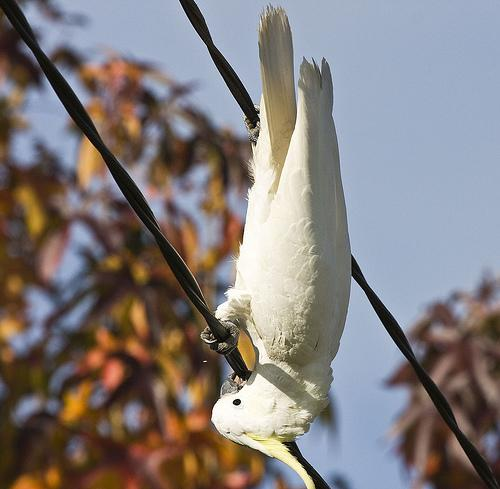Mention the primary subject in the image and their notable features. The image features an upside-down white parrot with a yellow headtop, a black eye, and a long tail, hanging by its feet on a black electrical wire. Create a brief narrative describing the scene in the image. Perched upside down, a curious white parrot with a yellow-feathered head and a long tail skillfully grips an electrical wire with its claws while also biting it with its beak. Offer a light-hearted and humorous description of the central subject and its behavior. Living life on the edge, the quirky white parrot inverts its world, daring to cling onto and chomp at the mysterious black wire with acrobatic flair. Briefly describe the main action happening in the picture. A white parrot, due to its mischievous nature, hangs upside down on a wire, using its beak and feet to grasp the electric line securely. Provide a creative and poetic description of the main object and its actions in the image. Gracefully draped in ivory plumage, an intriguing cockatoo adorned by a crown of sunlight careens upside down, while grasping and pecking at the ebony wire it dangles from. Provide a detailed description of the central object in the picture and its activity. An upside-down white parrot with a light yellow crest is hanging from a black wire, gripping it with its claws and biting the wire with its beak. Briefly describe the image's key subject and its surroundings. An upside-down white parrot with yellow head feathers is hanging from a black wire, with blurred trees and colorful leaves in the background. Concisely describe the focal point of the image and its actions. Hung upside down, a white parrot with a yellow feathered crown grips a black wire with its claws and beak. Convey in one sentence what the central object is doing and its most striking feature. A white parrot with a yellow head crest hangs upside down from a wire, gripping it with its feet and biting it with its beak. Explain what the main figure in the image is doing in a single sentence. The white parrot is hanging upside down from a wire by its claws, playfully biting on the wire with its beak. Do all the black wires in the image have a striped pattern on them? No captions mention any striped patterns on the wires, so stating there is one is misleading. Is the ocean visible in the sky between the branches of the tree? The sky appears in some captions (as in "sky between the wires") but there's no mention of the ocean, so asking about it is misleading. Are the feathers on the bird's head green and blue? The descriptors mention "yellow feathers on parrots head", so suggesting the feathers are green and blue is misleading. Is the parrot trying to eat a fruit on the tree? The parrot is described as biting the wire in several captions, so suggesting it's trying to eat a fruit on a tree is misleading. The bird seems to be sitting on a wooden branch. How thick is the branch? The bird is actually hanging on a wire ("bird on powerline", "parrot on wires", "black electrical wire") and not a wooden branch, so asking for thickness is misleading. Can you see a green bird sitting upright on the wire? The image has a "white parrot on wires" that is upside down, so describing it as green and sitting upright is incorrect and misleading. Please tell me how many small red eyes does the bird have? The captions describe the bird's eye as "tiny black eye", "the birds black eye", and "black eye on white bird", so suggesting it has multiple red eyes is misleading. I noticed a clear image of a tree in the background. What type of tree is it? The descriptors mention a "blurred image of a tree" and "colorful but blurry image of a tree", so asking for a specific type based on a clear image is misleading. Does the bird have blue wings spread wide while hanging on the wire? The bird's color is described as white, not blue (as in "white feathery body of the bird"), and there's no mention of its wings being spread, so making that assumption is misleading. Are the leaves on the tree next to the parrot purple? The descriptor actually says "multicolored leaves of the treebranch" and "orange and yellow leaves on tree", so implying the leaves are purple is misleading. 